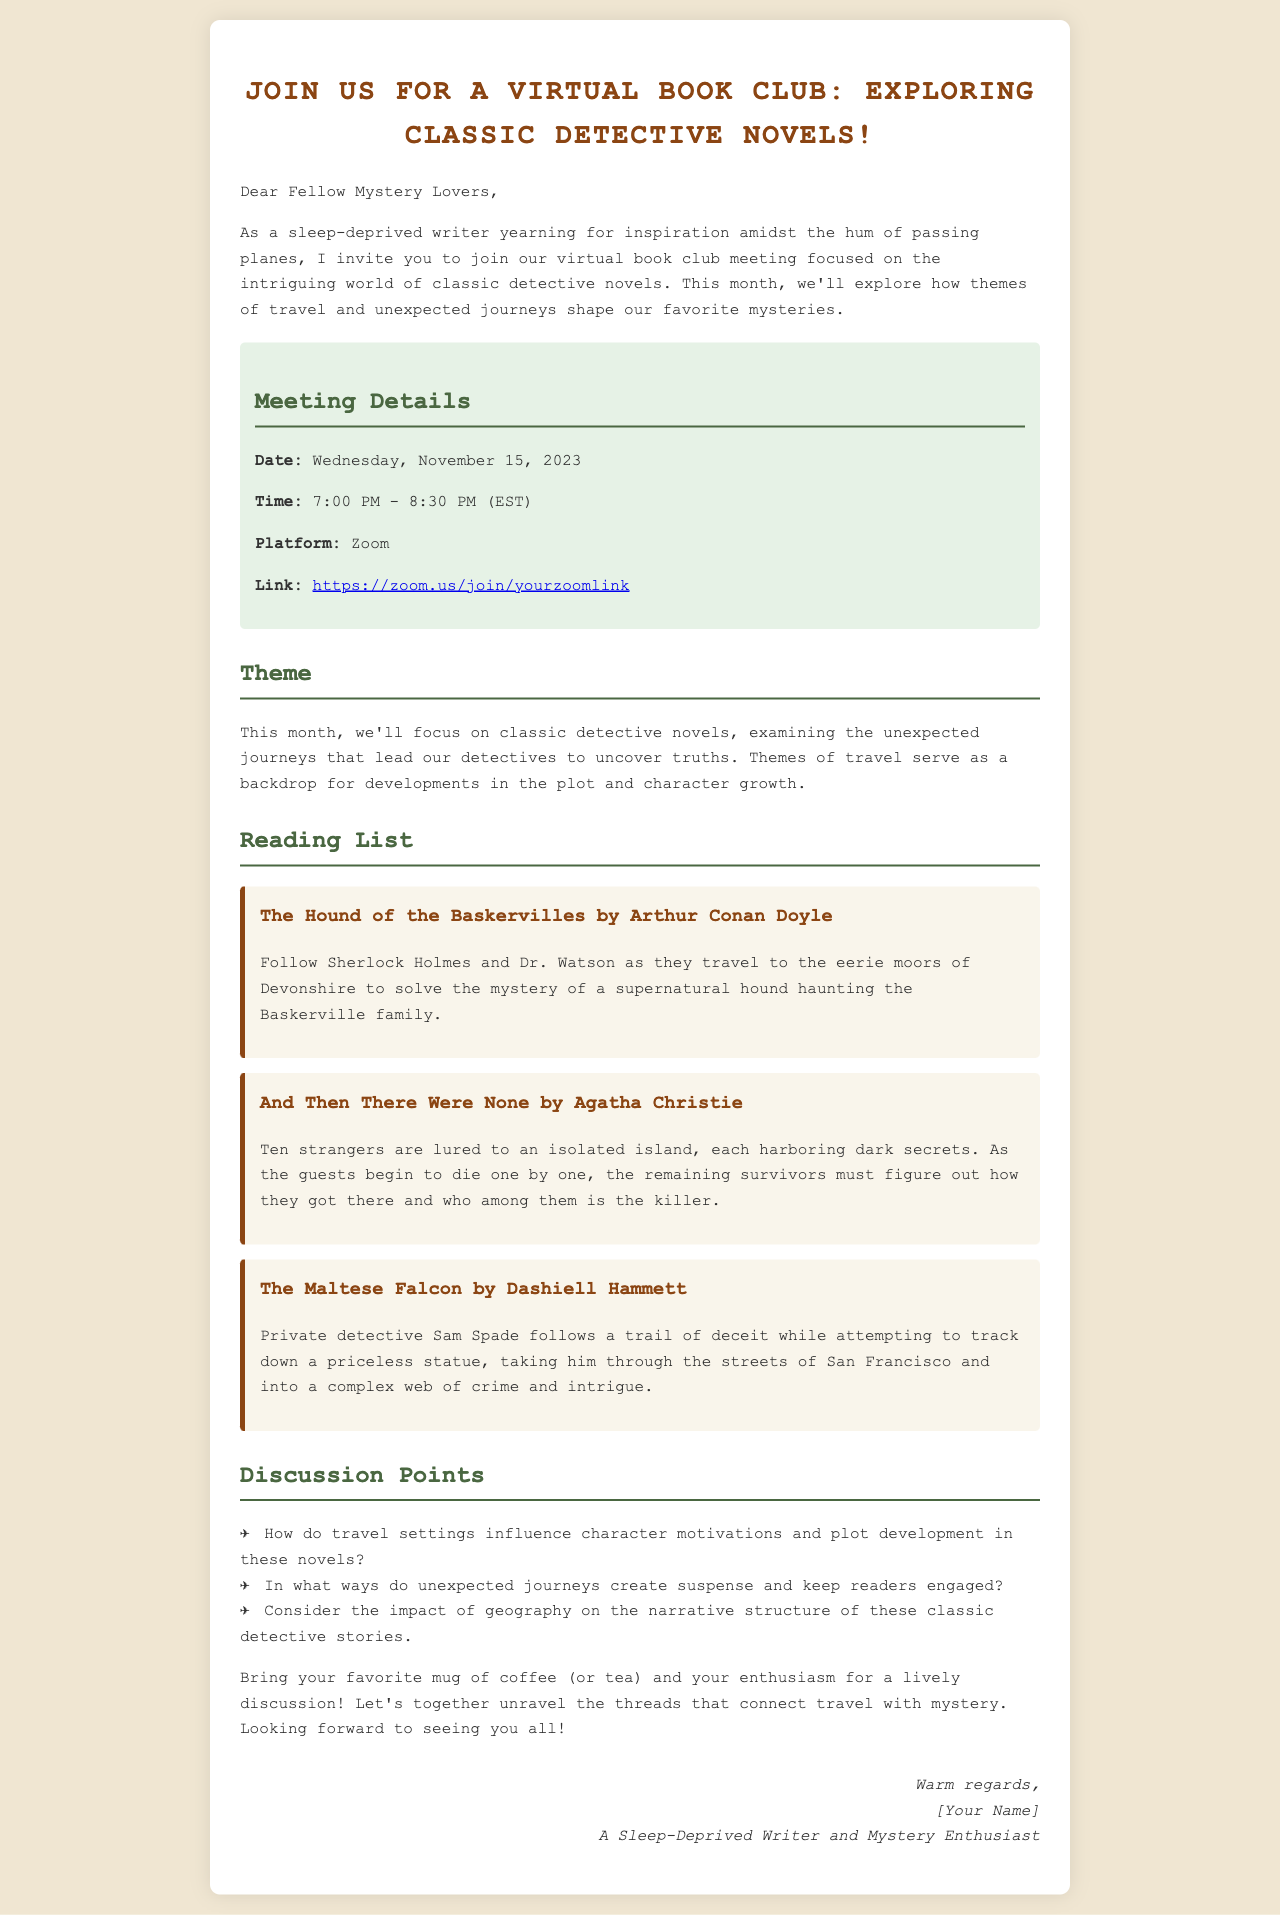What is the date of the virtual book club meeting? The date of the virtual book club meeting is clearly stated to be November 15, 2023.
Answer: November 15, 2023 What time does the meeting start? The email specifies the starting time of the meeting, which is 7:00 PM.
Answer: 7:00 PM Which platform will the meeting be held on? The email mentions that the meeting will take place on Zoom, providing a specific platform for the virtual gathering.
Answer: Zoom What is the title of the first book on the reading list? The email includes a reading list, and the first book mentioned is "The Hound of the Baskervilles."
Answer: The Hound of the Baskervilles How many discussion points are listed? The document lists three specific discussion points that participants will explore during the meeting.
Answer: 3 Why are travel themes significant in these novels? The document suggests that themes of travel and unexpected journeys have an impact on the plot development and character motivations in detective novels.
Answer: They influence plot and character motivations What should participants bring to the meeting? The email invites participants to bring their favorite mug of coffee or tea for a more engaging discussion.
Answer: Coffee or tea Who is the sender of the email? The signature at the end of the email indicates that the sender is a sleep-deprived writer and mystery enthusiast, specifically referred to as “[Your Name].”
Answer: [Your Name] What genre of novels is the focus of the book club? The email clearly states that the book club is focusing on classic detective novels.
Answer: Classic detective novels 